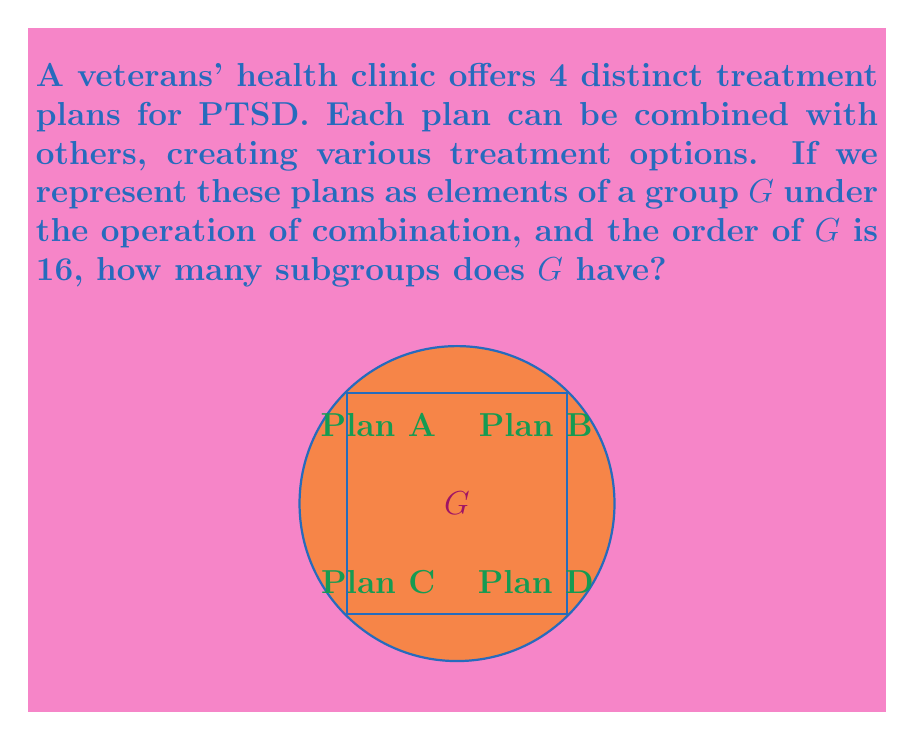Provide a solution to this math problem. Let's approach this step-by-step:

1) Given that there are 4 distinct treatment plans and the order of the group is 16, we can deduce that this is likely the group $C_2 \times C_2 \times C_2 \times C_2$, where $C_2$ is the cyclic group of order 2.

2) To find the number of subgroups, we can use the following theorem:
   The number of subgroups of $(C_2)^n$ is equal to the sum of Gaussian binomial coefficients:

   $$\sum_{k=0}^n \binom{n}{k}_2$$

   where $\binom{n}{k}_2$ is the Gaussian binomial coefficient.

3) In our case, $n = 4$ (as we have 4 $C_2$ factors). So we need to calculate:

   $$\sum_{k=0}^4 \binom{4}{k}_2$$

4) The Gaussian binomial coefficients for $q=2$ and $n=4$ are:
   
   $\binom{4}{0}_2 = 1$
   $\binom{4}{1}_2 = 15$
   $\binom{4}{2}_2 = 35$
   $\binom{4}{3}_2 = 15$
   $\binom{4}{4}_2 = 1$

5) Sum these up:

   $1 + 15 + 35 + 15 + 1 = 67$

Therefore, the group $G$ has 67 subgroups.
Answer: 67 